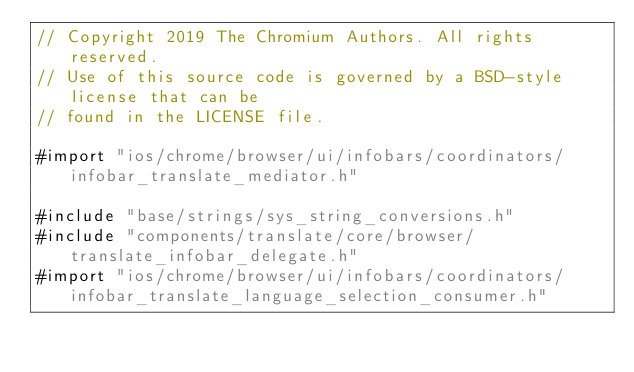<code> <loc_0><loc_0><loc_500><loc_500><_ObjectiveC_>// Copyright 2019 The Chromium Authors. All rights reserved.
// Use of this source code is governed by a BSD-style license that can be
// found in the LICENSE file.

#import "ios/chrome/browser/ui/infobars/coordinators/infobar_translate_mediator.h"

#include "base/strings/sys_string_conversions.h"
#include "components/translate/core/browser/translate_infobar_delegate.h"
#import "ios/chrome/browser/ui/infobars/coordinators/infobar_translate_language_selection_consumer.h"</code> 